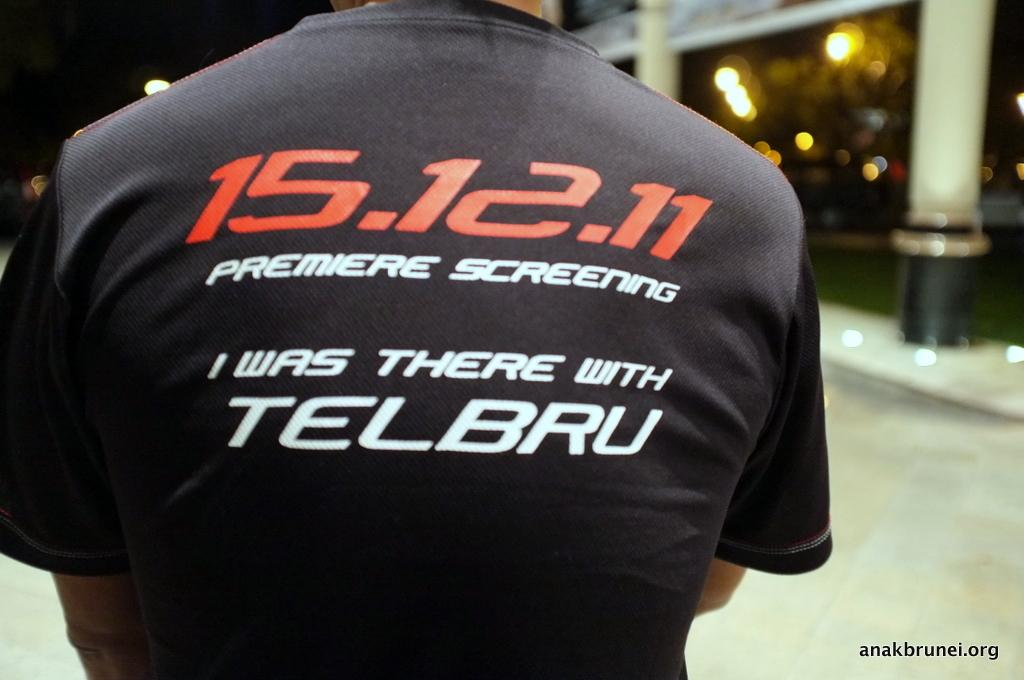<image>
Present a compact description of the photo's key features. Man wearing a shirt, the back of the shirt says 15.12.11 Premiere Screening I was there with Telbru. 